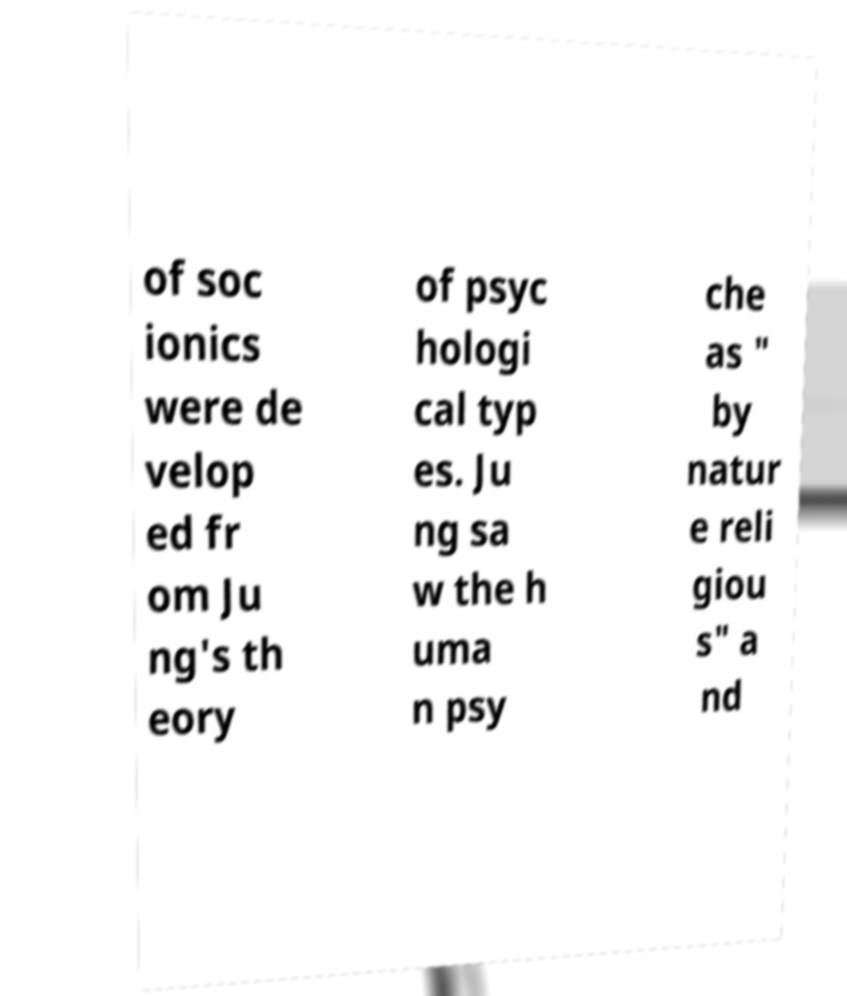Could you assist in decoding the text presented in this image and type it out clearly? of soc ionics were de velop ed fr om Ju ng's th eory of psyc hologi cal typ es. Ju ng sa w the h uma n psy che as " by natur e reli giou s" a nd 